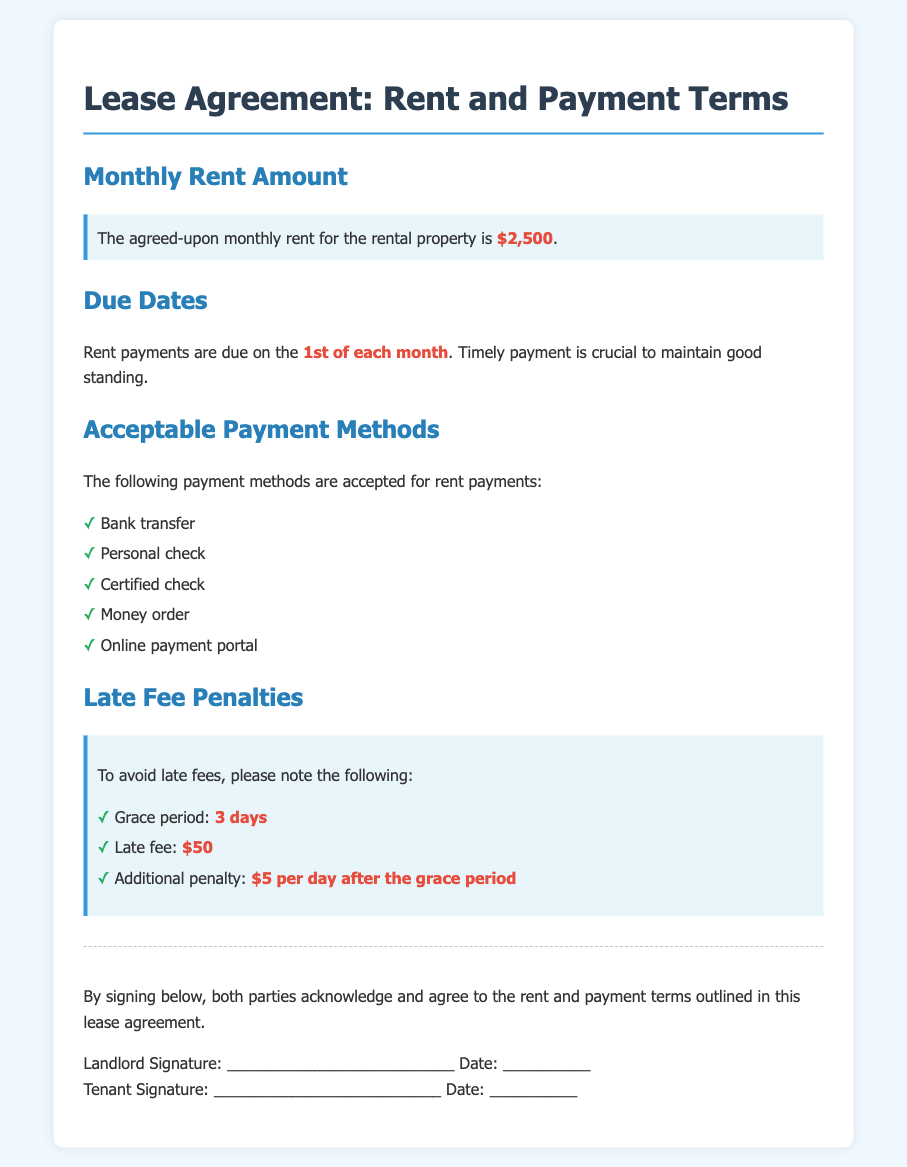What is the monthly rent amount? The document states that the agreed-upon monthly rent for the rental property is highlighted as $2,500.
Answer: $2,500 When is the rent due? The due date for rent payments is indicated in the document as the 1st of each month.
Answer: 1st of each month What is the grace period for late rent payments? The grace period for rent payments is specified in the document, allowing an additional time frame of 3 days before penalties are applied.
Answer: 3 days How much is the late fee? The document details that the late fee for overdue rent is stated as $50.
Answer: $50 What payment methods are accepted? The accepted payment methods list includes bank transfer, personal check, certified check, money order, and online payment portal as mentioned in the document.
Answer: Bank transfer, personal check, certified check, money order, online payment portal What is the additional penalty after the grace period? The document specifies that the additional penalty accrued is $5 per day after the grace period of 3 days.
Answer: $5 per day Who needs to sign the lease agreement? The document indicates that both the landlord and tenant need to provide their signatures to acknowledge the terms.
Answer: Landlord and Tenant Is online payment an option? The document clearly states that one of the acceptable payment methods is an online payment portal.
Answer: Yes 